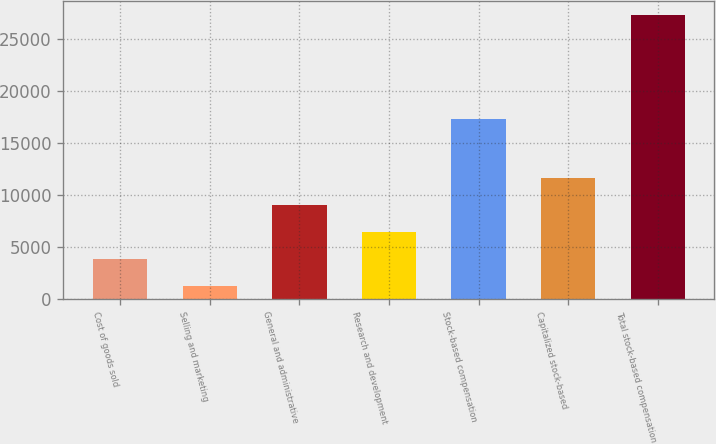<chart> <loc_0><loc_0><loc_500><loc_500><bar_chart><fcel>Cost of goods sold<fcel>Selling and marketing<fcel>General and administrative<fcel>Research and development<fcel>Stock-based compensation<fcel>Capitalized stock-based<fcel>Total stock-based compensation<nl><fcel>3840<fcel>1232<fcel>9056<fcel>6448<fcel>17329<fcel>11664<fcel>27312<nl></chart> 